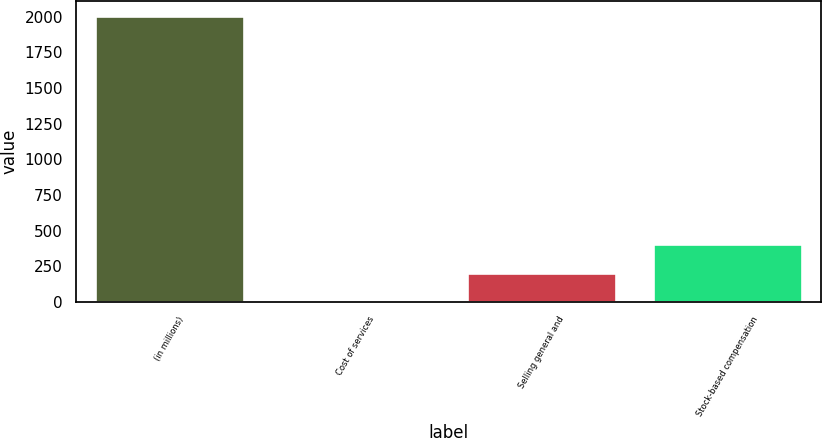Convert chart to OTSL. <chart><loc_0><loc_0><loc_500><loc_500><bar_chart><fcel>(in millions)<fcel>Cost of services<fcel>Selling general and<fcel>Stock-based compensation<nl><fcel>2008<fcel>2.4<fcel>202.96<fcel>403.52<nl></chart> 